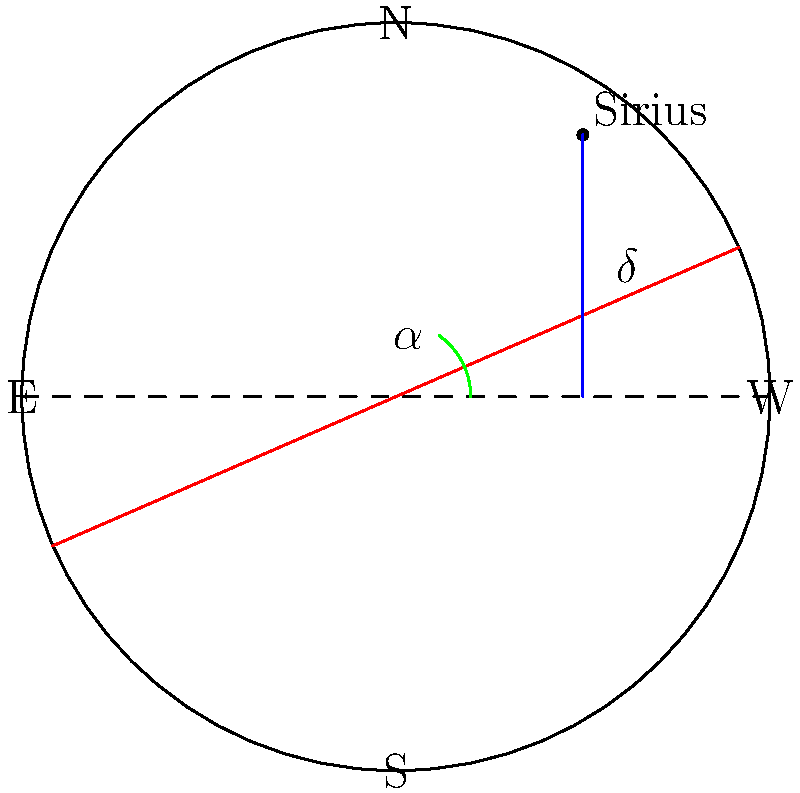In translating an ancient Egyptian star chart to modern celestial coordinates, you encounter a representation of Sirius. Given that the Egyptians measured celestial positions relative to the ecliptic, how would you convert Sirius's position to the equatorial coordinate system used today? Specifically, what additional information would you need to determine its right ascension ($\alpha$) and declination ($\delta$)? To convert Sirius's position from the ancient Egyptian ecliptic-based system to the modern equatorial coordinate system, we need to consider the following steps:

1. Ancient Egyptian system: Based on the ecliptic (plane of Earth's orbit around the Sun).
2. Modern equatorial system: Based on the celestial equator (projection of Earth's equator onto the celestial sphere).

To make this conversion, we need:

a) Sirius's ecliptic longitude ($\lambda$) and latitude ($\beta$) from the Egyptian chart.
b) The obliquity of the ecliptic ($\varepsilon$), which is the angle between the ecliptic and celestial equator (approximately 23.5°).

The conversion formulas are:

$$\sin(\delta) = \sin(\beta)\cos(\varepsilon) + \cos(\beta)\sin(\varepsilon)\sin(\lambda)$$
$$\tan(\alpha) = \frac{\sin(\lambda)\cos(\varepsilon) - \tan(\beta)\sin(\varepsilon)}{\cos(\lambda)}$$

Where:
$\delta$ is declination
$\alpha$ is right ascension
$\lambda$ is ecliptic longitude
$\beta$ is ecliptic latitude
$\varepsilon$ is obliquity of the ecliptic

Therefore, to determine Sirius's right ascension and declination, we would need:

1. Sirius's ecliptic longitude ($\lambda$) from the Egyptian chart
2. Sirius's ecliptic latitude ($\beta$) from the Egyptian chart
3. The precise obliquity of the ecliptic ($\varepsilon$) for the epoch of the Egyptian chart

With these three pieces of information, we could apply the conversion formulas to obtain Sirius's position in the modern equatorial coordinate system.
Answer: Ecliptic longitude ($\lambda$), ecliptic latitude ($\beta$), and obliquity of the ecliptic ($\varepsilon$) 